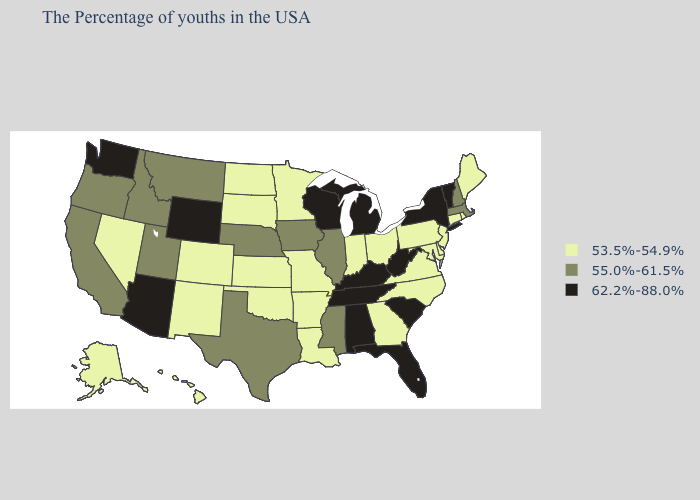What is the lowest value in states that border Connecticut?
Concise answer only. 53.5%-54.9%. What is the lowest value in the West?
Quick response, please. 53.5%-54.9%. What is the lowest value in the USA?
Short answer required. 53.5%-54.9%. Does Vermont have the highest value in the Northeast?
Answer briefly. Yes. What is the highest value in the USA?
Give a very brief answer. 62.2%-88.0%. Which states have the highest value in the USA?
Answer briefly. Vermont, New York, South Carolina, West Virginia, Florida, Michigan, Kentucky, Alabama, Tennessee, Wisconsin, Wyoming, Arizona, Washington. Which states have the highest value in the USA?
Write a very short answer. Vermont, New York, South Carolina, West Virginia, Florida, Michigan, Kentucky, Alabama, Tennessee, Wisconsin, Wyoming, Arizona, Washington. What is the highest value in the USA?
Answer briefly. 62.2%-88.0%. What is the value of Iowa?
Short answer required. 55.0%-61.5%. What is the value of New Mexico?
Write a very short answer. 53.5%-54.9%. Does the first symbol in the legend represent the smallest category?
Keep it brief. Yes. What is the lowest value in the USA?
Quick response, please. 53.5%-54.9%. How many symbols are there in the legend?
Keep it brief. 3. Name the states that have a value in the range 55.0%-61.5%?
Keep it brief. Massachusetts, New Hampshire, Illinois, Mississippi, Iowa, Nebraska, Texas, Utah, Montana, Idaho, California, Oregon. Does Hawaii have a lower value than Delaware?
Short answer required. No. 